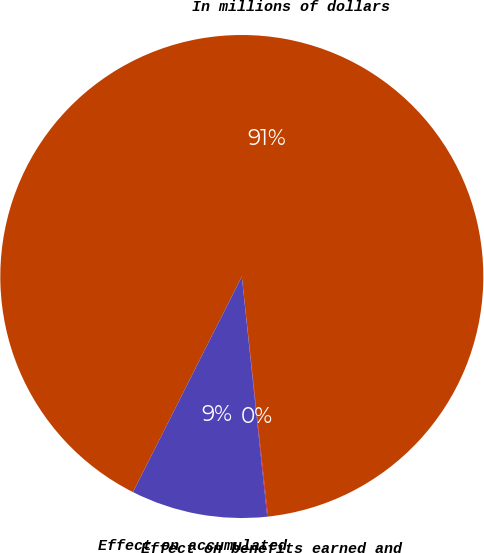Convert chart. <chart><loc_0><loc_0><loc_500><loc_500><pie_chart><fcel>In millions of dollars<fcel>Effect on benefits earned and<fcel>Effect on accumulated<nl><fcel>90.83%<fcel>0.05%<fcel>9.12%<nl></chart> 